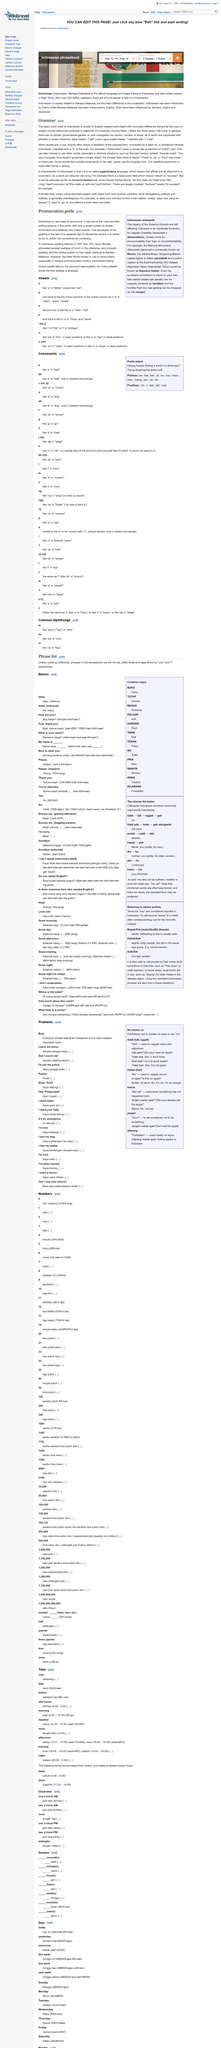Highlight a few significant elements in this photo. Indonesian writing is identical to the writing system used in Bahasa Malaysia. In 1947 and 1972, Indonesia underwent spelling reforms. The use of older forms of Indonesian pronunciation still exists today. In Indonesian grammar, the noun or subject always comes before the predicate or adjective. There are no plurals for person, number, or tense in Indonesian. 